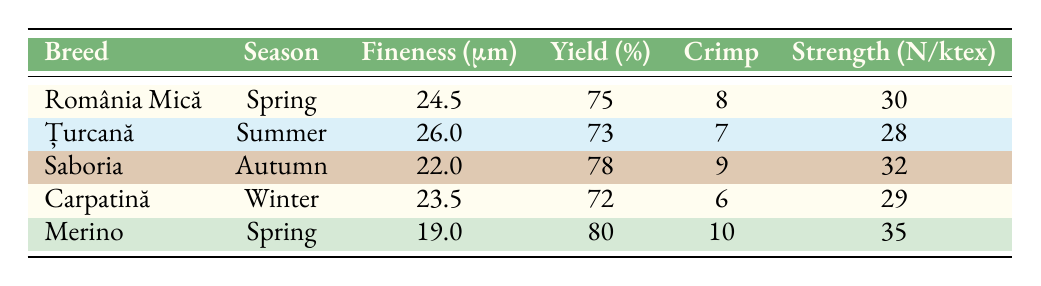What is the fineness of the wool from the breed Romania Mică in Spring? The table shows that the fineness for Romania Mică during Spring is listed directly under the "Fineness (μm)" column, with a value of 24.5 microns.
Answer: 24.5 Which breed has the highest yield percentage and what is that percentage? By scanning through the "Yield (%)" column, I see that the breed Merino has the highest yield percentage of 80.
Answer: 80 Is the crimp value for the breed Țurcană greater than that of the breed Carpatină? For Țurcană, the crimp value is 7, whereas for Carpatină, it is 6. Therefore, 7 > 6 indicates that Țurcană has a greater crimp value than Carpatină.
Answer: Yes What is the average fineness of wool from the breeds listed in Spring? To calculate the average fineness for breeds in Spring, I take the fineness values for Romania Mică (24.5) and Merino (19.0), sum them (24.5 + 19.0 = 43.5), and divide by the number of breeds (2): 43.5 / 2 = 21.75.
Answer: 21.75 What strength value does the wool from the Saboria breed exhibit in Autumn? Looking at the table, the strength value for Saboria in Autumn is listed as 32 N/ktex directly under the "Strength (N/ktex)" column.
Answer: 32 Is the yield percentage for the breed Carpatină lower than that for Saboria? The yield percentage for Carpatină is 72%, while for Saboria it is 78%. Since 72 < 78, it confirms that Carpatină's yield percentage is indeed lower.
Answer: Yes Which breed's wool demonstrates the highest strength and what is that strength? Examining the "Strength (N/ktex)" column, the highest value is seen for the Merino breed with a strength of 35 N/ktex.
Answer: 35 If you combine the fineness values of Țurcană and Saboria, what is their total fineness? The fineness of Țurcană is 26.0 μm and Saboria is 22.0 μm. Adding these values together, 26.0 + 22.0 = 48.0 μm gives us the total fineness.
Answer: 48.0 Which season has the highest crimp value among the breeds listed? The crimp values from the table show Saboria with 9, Romania Mică with 8, Țurcană with 7, Carpatină with 6, and Merino with 10. The highest crimp value is attributed to Merino at 10.
Answer: 10 